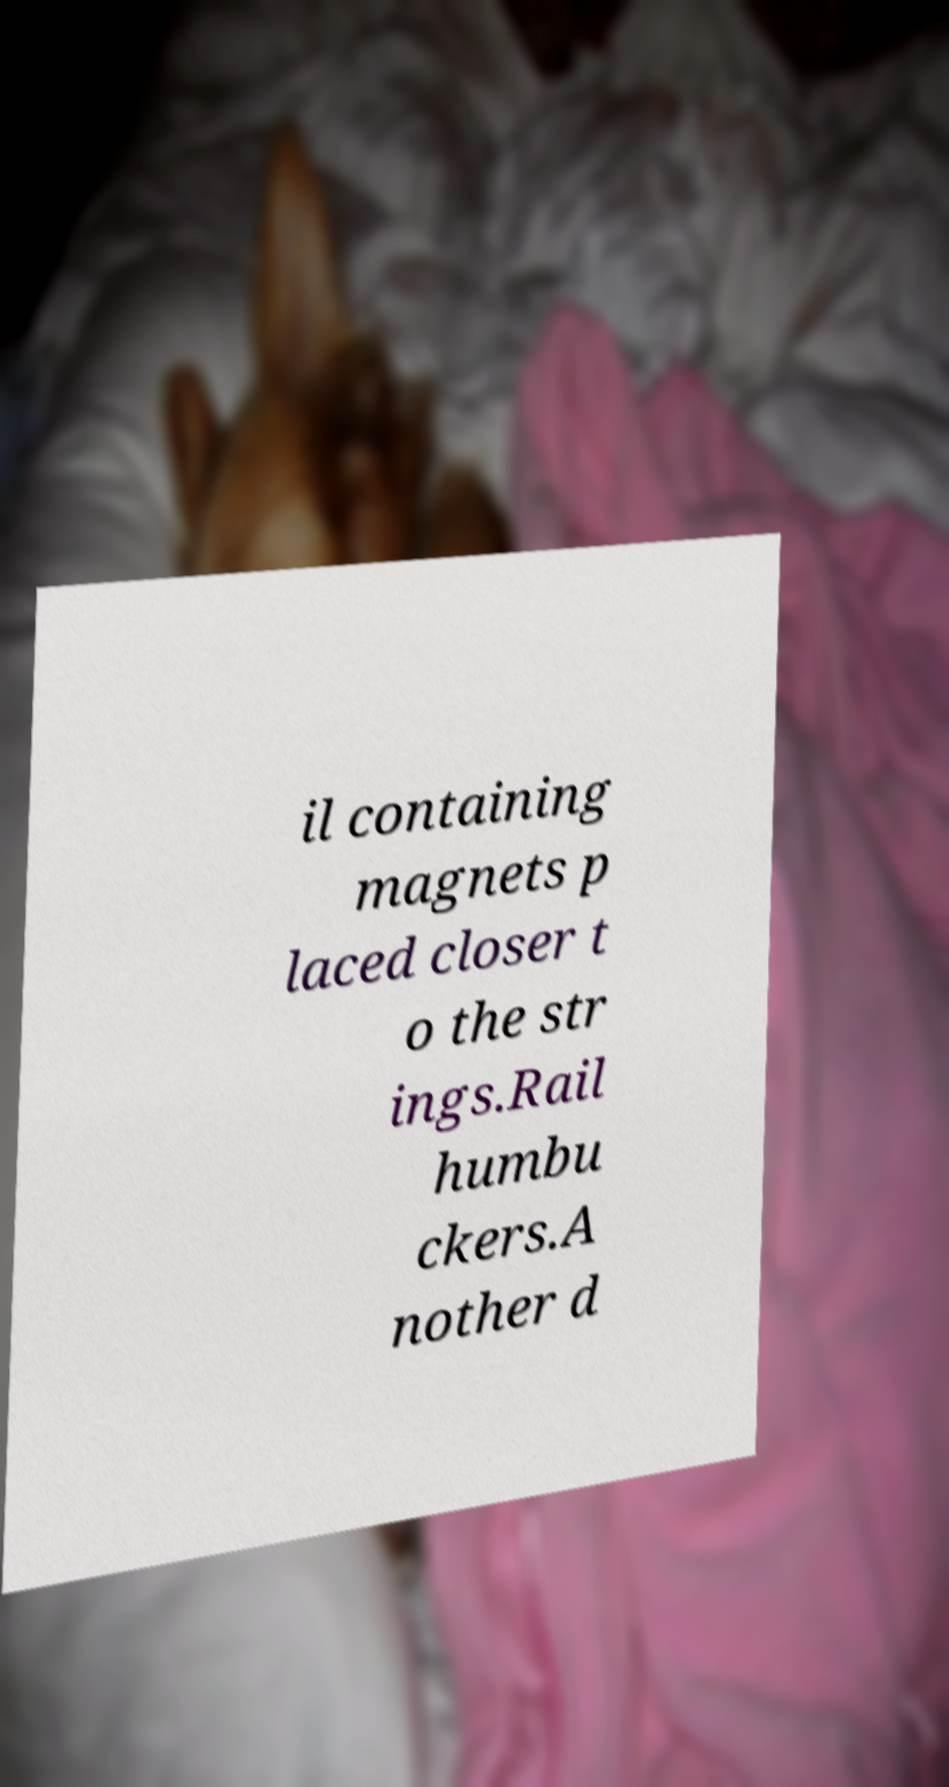What messages or text are displayed in this image? I need them in a readable, typed format. il containing magnets p laced closer t o the str ings.Rail humbu ckers.A nother d 